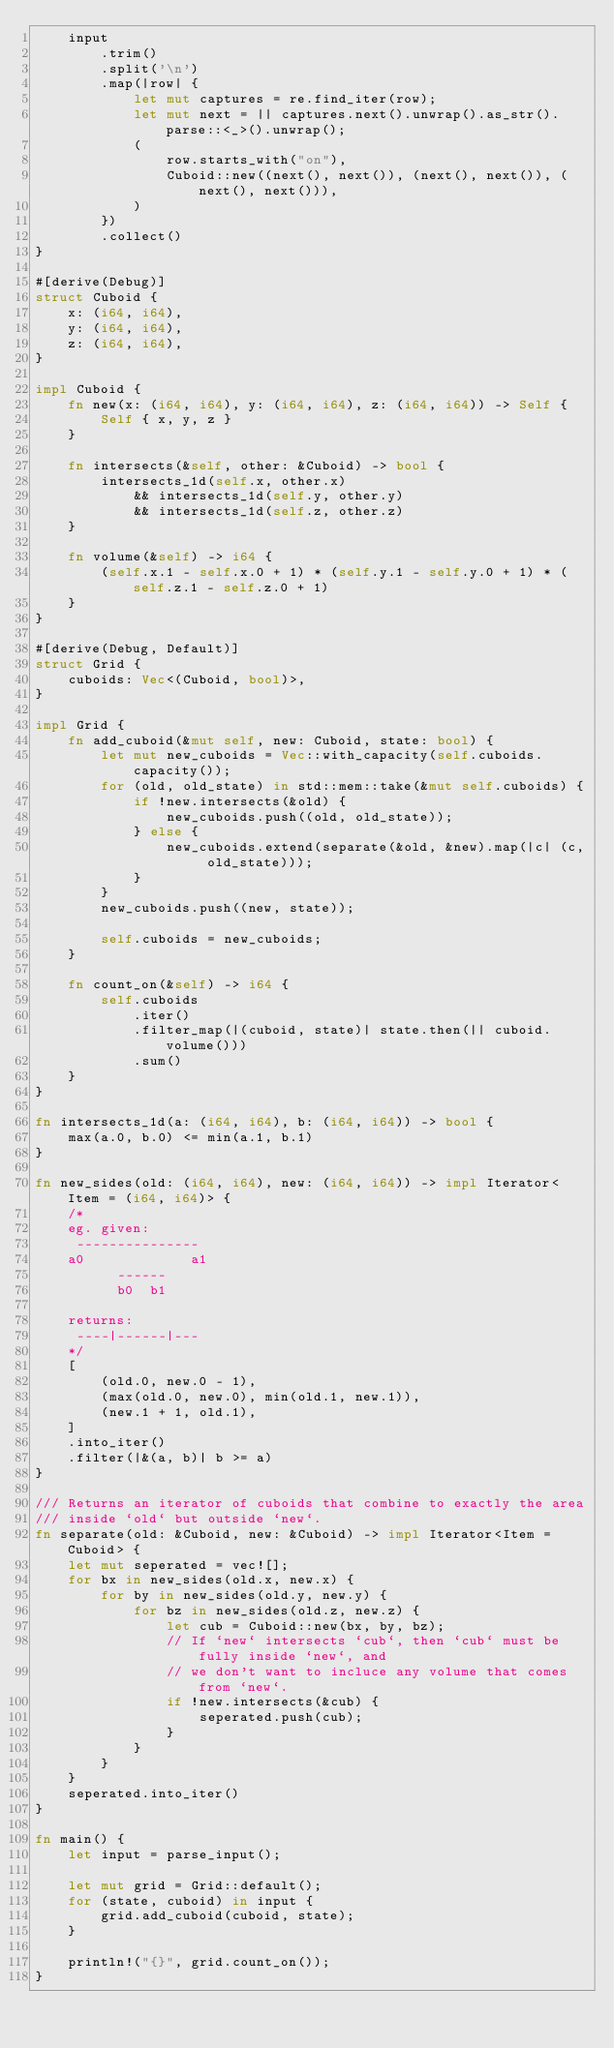Convert code to text. <code><loc_0><loc_0><loc_500><loc_500><_Rust_>    input
        .trim()
        .split('\n')
        .map(|row| {
            let mut captures = re.find_iter(row);
            let mut next = || captures.next().unwrap().as_str().parse::<_>().unwrap();
            (
                row.starts_with("on"),
                Cuboid::new((next(), next()), (next(), next()), (next(), next())),
            )
        })
        .collect()
}

#[derive(Debug)]
struct Cuboid {
    x: (i64, i64),
    y: (i64, i64),
    z: (i64, i64),
}

impl Cuboid {
    fn new(x: (i64, i64), y: (i64, i64), z: (i64, i64)) -> Self {
        Self { x, y, z }
    }

    fn intersects(&self, other: &Cuboid) -> bool {
        intersects_1d(self.x, other.x)
            && intersects_1d(self.y, other.y)
            && intersects_1d(self.z, other.z)
    }

    fn volume(&self) -> i64 {
        (self.x.1 - self.x.0 + 1) * (self.y.1 - self.y.0 + 1) * (self.z.1 - self.z.0 + 1)
    }
}

#[derive(Debug, Default)]
struct Grid {
    cuboids: Vec<(Cuboid, bool)>,
}

impl Grid {
    fn add_cuboid(&mut self, new: Cuboid, state: bool) {
        let mut new_cuboids = Vec::with_capacity(self.cuboids.capacity());
        for (old, old_state) in std::mem::take(&mut self.cuboids) {
            if !new.intersects(&old) {
                new_cuboids.push((old, old_state));
            } else {
                new_cuboids.extend(separate(&old, &new).map(|c| (c, old_state)));
            }
        }
        new_cuboids.push((new, state));

        self.cuboids = new_cuboids;
    }

    fn count_on(&self) -> i64 {
        self.cuboids
            .iter()
            .filter_map(|(cuboid, state)| state.then(|| cuboid.volume()))
            .sum()
    }
}

fn intersects_1d(a: (i64, i64), b: (i64, i64)) -> bool {
    max(a.0, b.0) <= min(a.1, b.1)
}

fn new_sides(old: (i64, i64), new: (i64, i64)) -> impl Iterator<Item = (i64, i64)> {
    /*
    eg. given:
     ---------------
    a0             a1
          ------
          b0  b1

    returns:
     ----|------|---
    */
    [
        (old.0, new.0 - 1),
        (max(old.0, new.0), min(old.1, new.1)),
        (new.1 + 1, old.1),
    ]
    .into_iter()
    .filter(|&(a, b)| b >= a)
}

/// Returns an iterator of cuboids that combine to exactly the area
/// inside `old` but outside `new`.
fn separate(old: &Cuboid, new: &Cuboid) -> impl Iterator<Item = Cuboid> {
    let mut seperated = vec![];
    for bx in new_sides(old.x, new.x) {
        for by in new_sides(old.y, new.y) {
            for bz in new_sides(old.z, new.z) {
                let cub = Cuboid::new(bx, by, bz);
                // If `new` intersects `cub`, then `cub` must be fully inside `new`, and
                // we don't want to incluce any volume that comes from `new`.
                if !new.intersects(&cub) {
                    seperated.push(cub);
                }
            }
        }
    }
    seperated.into_iter()
}

fn main() {
    let input = parse_input();

    let mut grid = Grid::default();
    for (state, cuboid) in input {
        grid.add_cuboid(cuboid, state);
    }

    println!("{}", grid.count_on());
}
</code> 